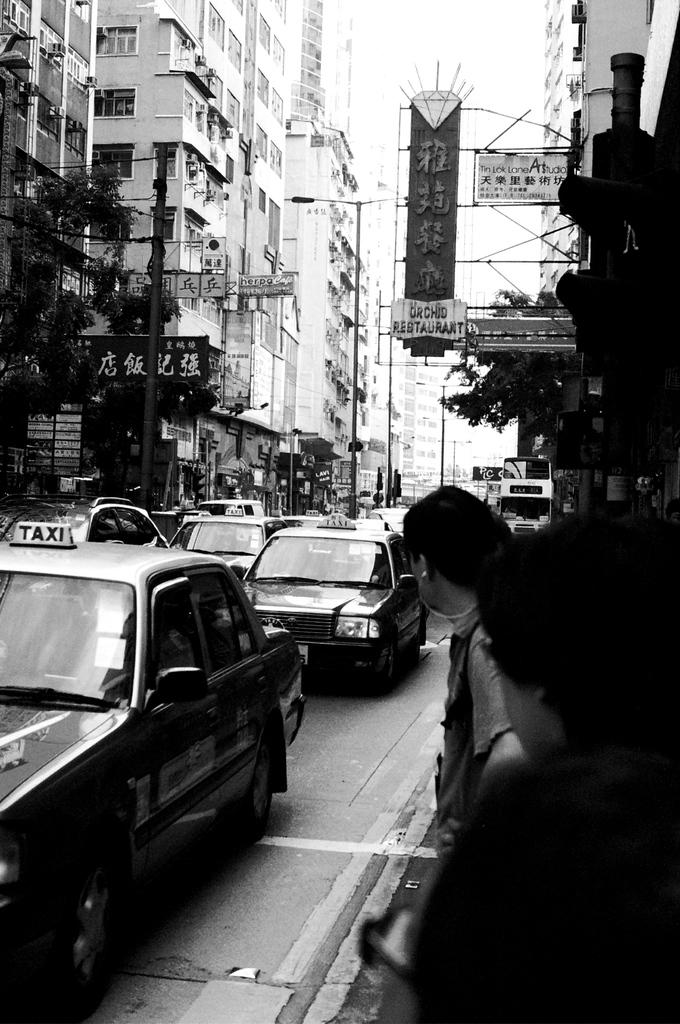Provide a one-sentence caption for the provided image. a black and white photo with taxi cars in the street. 